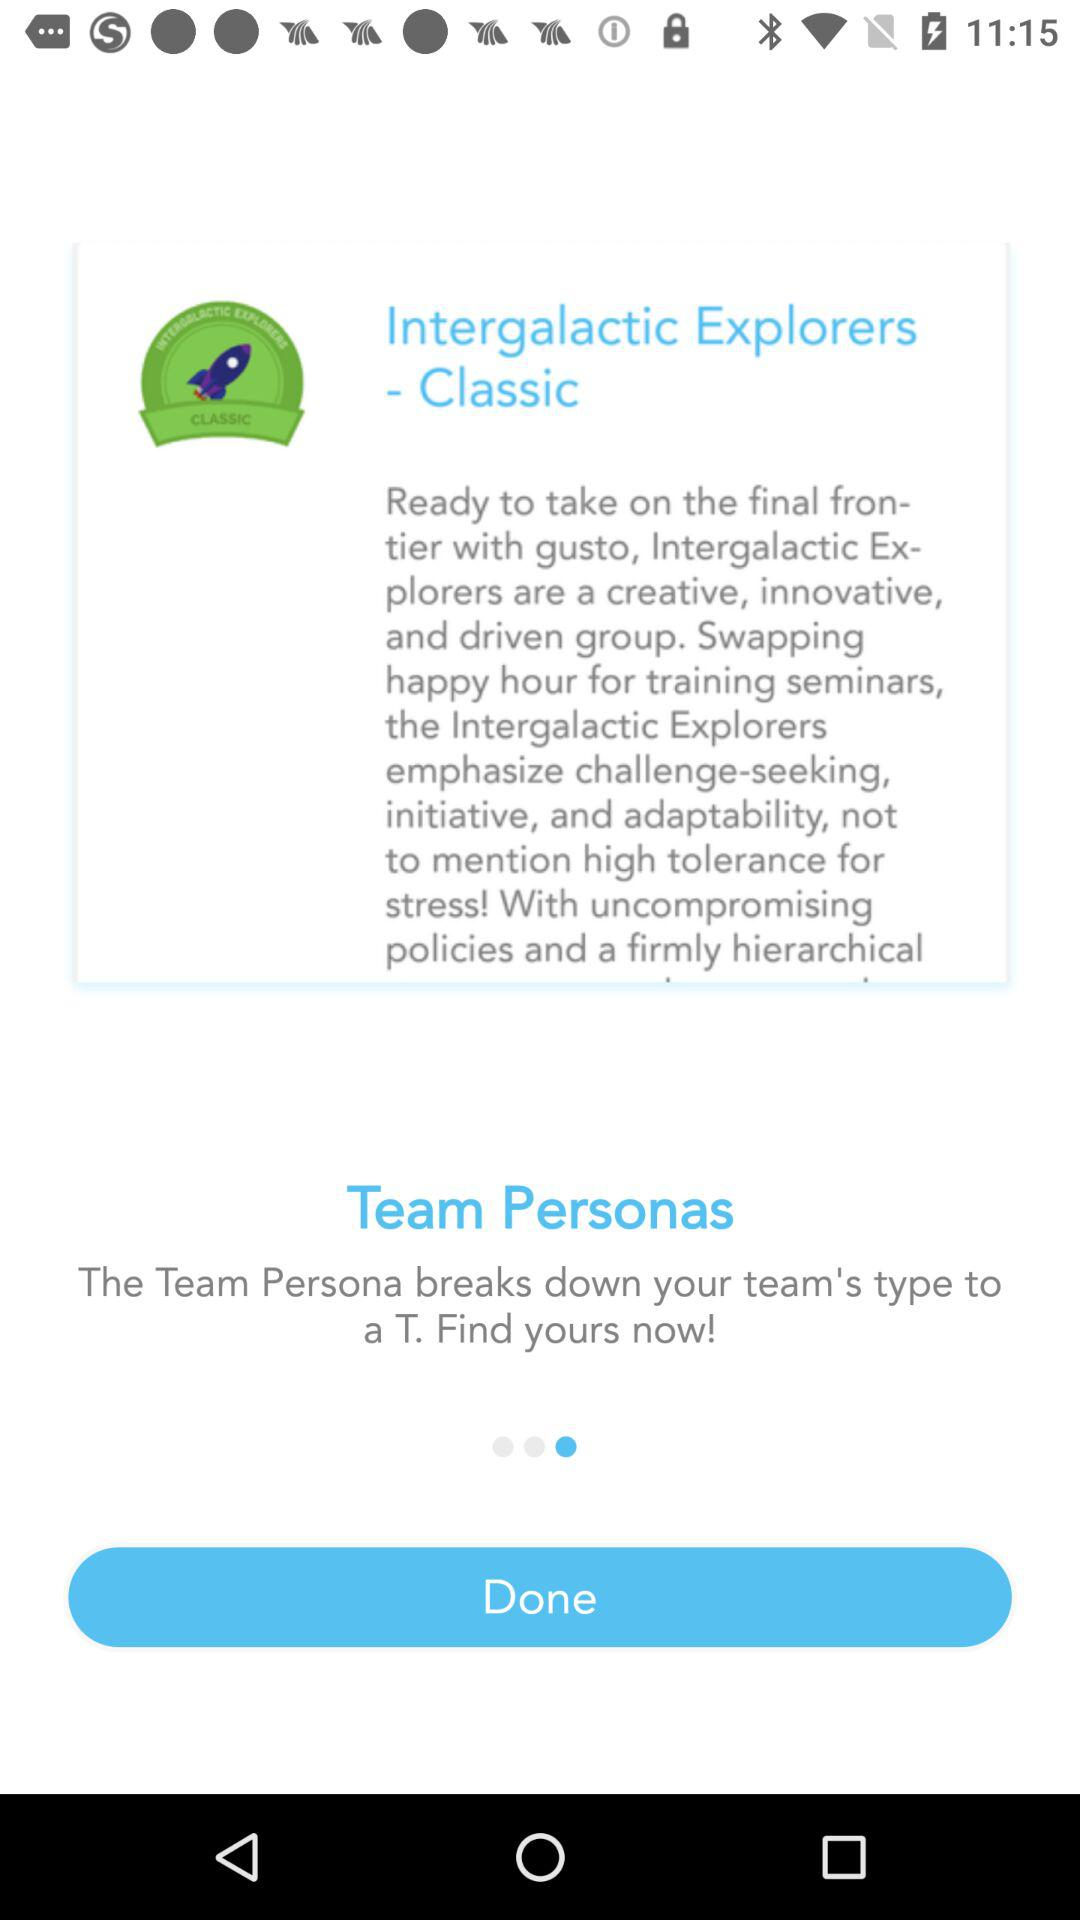What is the name of the application?
When the provided information is insufficient, respond with <no answer>. <no answer> 